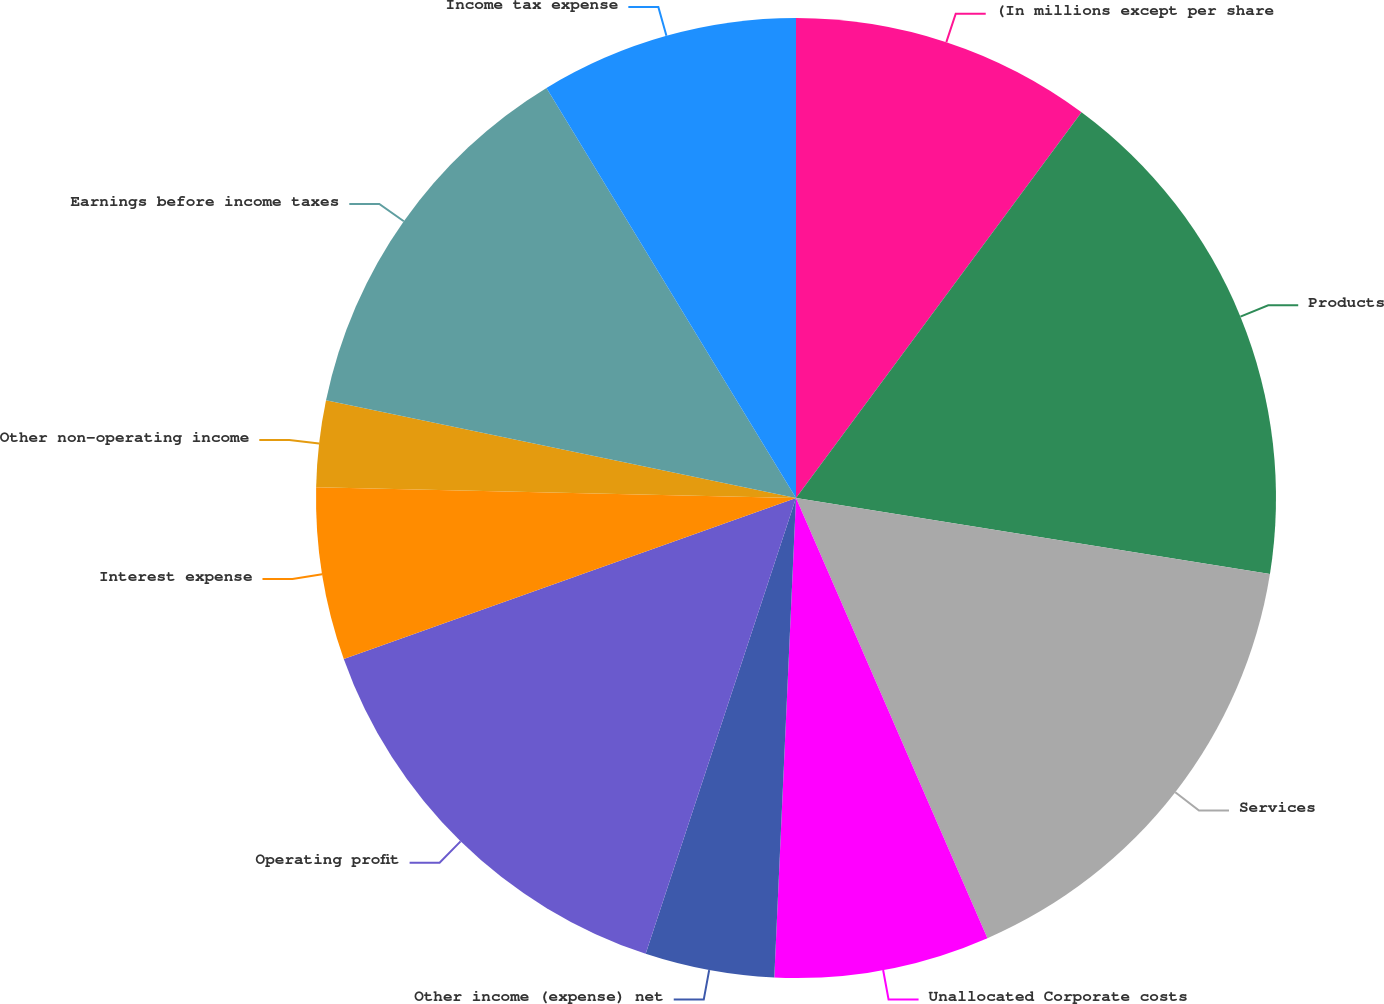Convert chart to OTSL. <chart><loc_0><loc_0><loc_500><loc_500><pie_chart><fcel>(In millions except per share<fcel>Products<fcel>Services<fcel>Unallocated Corporate costs<fcel>Other income (expense) net<fcel>Operating profit<fcel>Interest expense<fcel>Other non-operating income<fcel>Earnings before income taxes<fcel>Income tax expense<nl><fcel>10.14%<fcel>17.39%<fcel>15.94%<fcel>7.25%<fcel>4.35%<fcel>14.49%<fcel>5.8%<fcel>2.9%<fcel>13.04%<fcel>8.7%<nl></chart> 